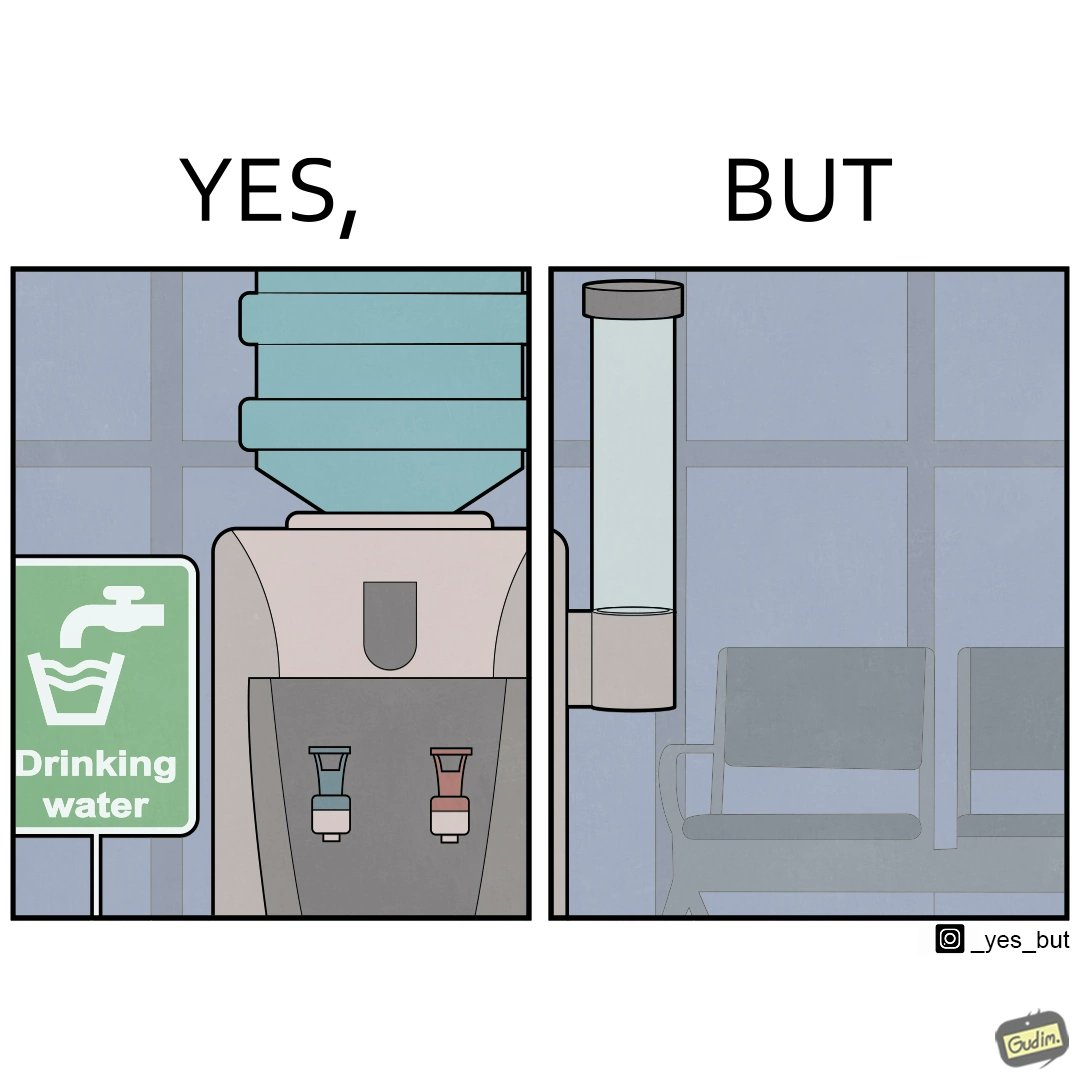Does this image contain satire or humor? Yes, this image is satirical. 